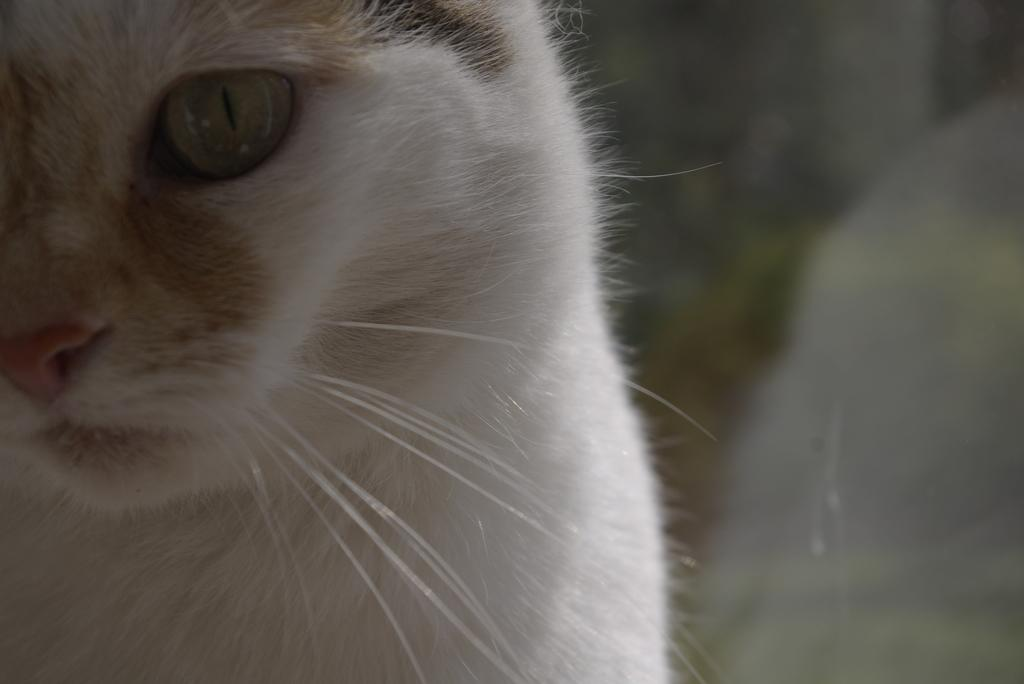What type of animal is in the image? There is a cat in the image. Can you describe the color of the cat? The cat is white in color. What type of day is depicted in the image? The image does not depict a day; it only shows a white cat. Can you see any ducks in the image? There are no ducks present in the image. 